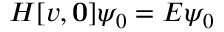<formula> <loc_0><loc_0><loc_500><loc_500>H [ v , 0 ] \psi _ { 0 } = E \psi _ { 0 }</formula> 